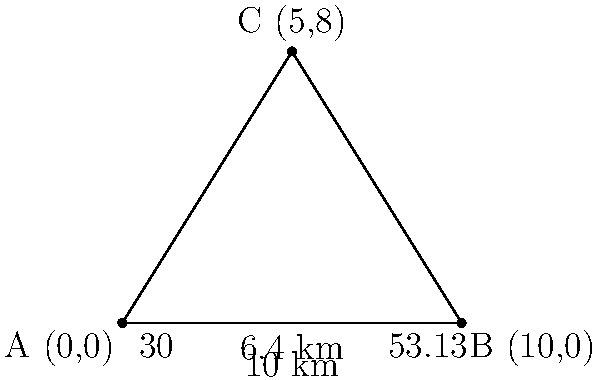A medical supply truck needs to be located using triangulation from three tracking stations. Two of the stations, A and B, are 10 km apart on a straight east-west line. The truck's signal is received at station A at an angle of 30° east of north, and at station B at an angle of 53.13° west of north. Calculate the distance of the truck from station A. Let's approach this step-by-step:

1) First, we can see that this forms a triangle, with the truck at point C and the two stations at points A and B.

2) We know the distance between A and B is 10 km, which forms the base of our triangle.

3) We're given two angles:
   - At A: 90° - 30° = 60° (since 30° is east of north)
   - At B: 90° - 53.13° = 36.87° (since 53.13° is west of north)

4) In a triangle, the sum of all angles is 180°. So we can find the angle at C:
   $180° - (60° + 36.87°) = 83.13°$

5) Now we have a triangle where we know all angles and one side. We can use the sine law:

   $\frac{a}{\sin A} = \frac{b}{\sin B} = \frac{c}{\sin C}$

   Where $a$, $b$, and $c$ are the sides opposite to angles $A$, $B$, and $C$ respectively.

6) We want to find the distance from A to C. Let's call this distance $x$. We can set up the sine law:

   $\frac{x}{\sin 36.87°} = \frac{10}{\sin 83.13°}$

7) Solving for $x$:

   $x = \frac{10 \sin 36.87°}{\sin 83.13°}$

8) Using a calculator:

   $x \approx 6.4$ km

Therefore, the distance of the truck from station A is approximately 6.4 km.
Answer: 6.4 km 